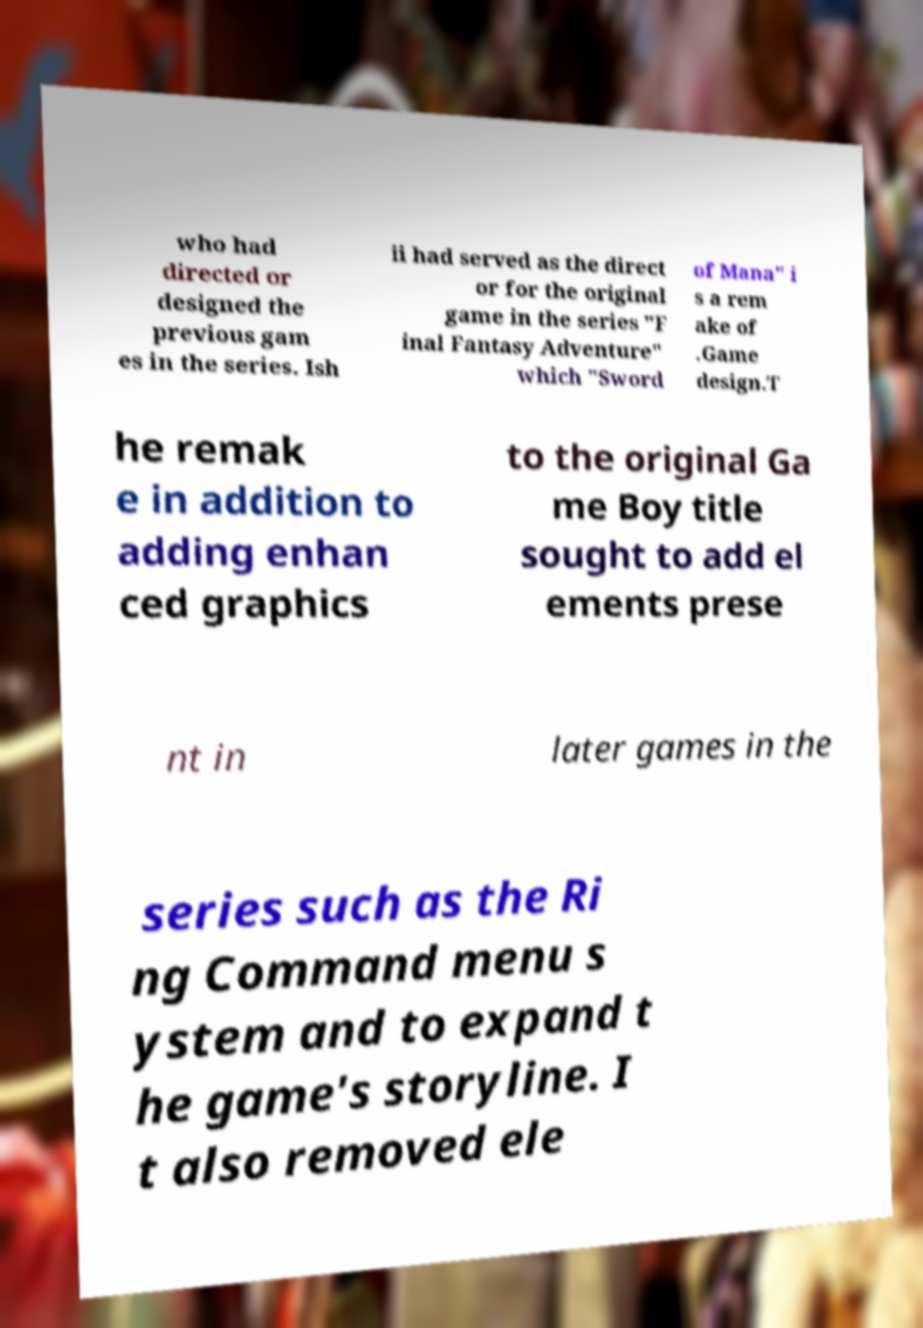For documentation purposes, I need the text within this image transcribed. Could you provide that? who had directed or designed the previous gam es in the series. Ish ii had served as the direct or for the original game in the series "F inal Fantasy Adventure" which "Sword of Mana" i s a rem ake of .Game design.T he remak e in addition to adding enhan ced graphics to the original Ga me Boy title sought to add el ements prese nt in later games in the series such as the Ri ng Command menu s ystem and to expand t he game's storyline. I t also removed ele 